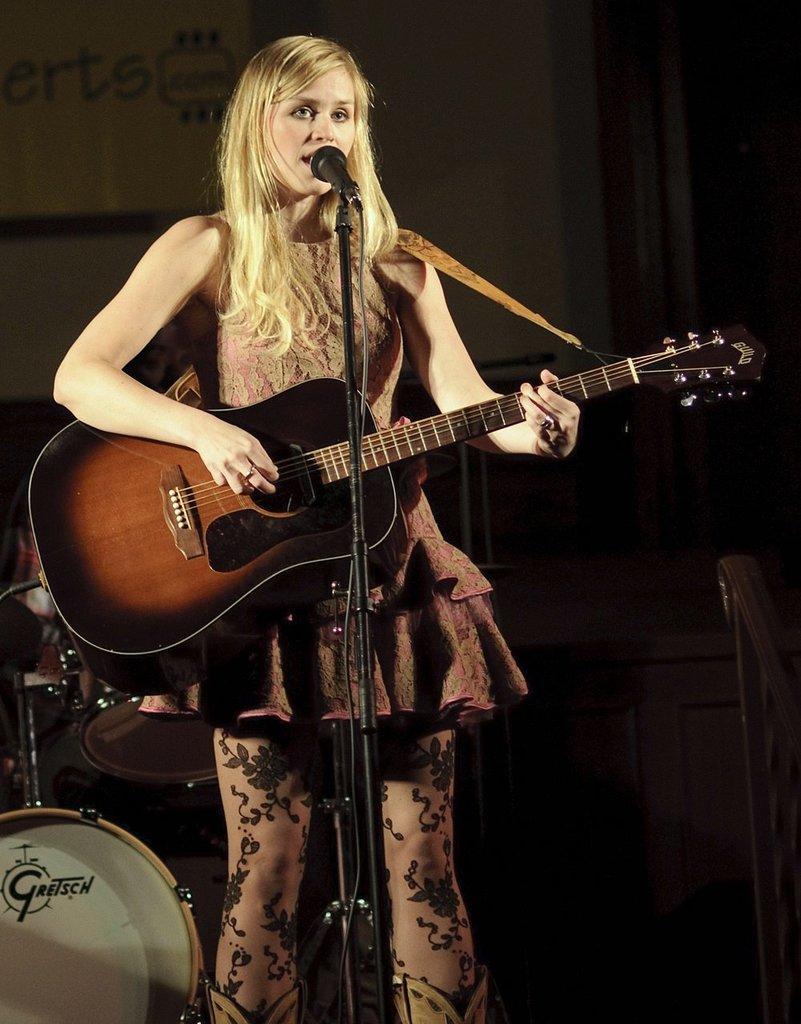In one or two sentences, can you explain what this image depicts? A woman is singing on mic and playing guitar. Behind her there are musical instruments. 